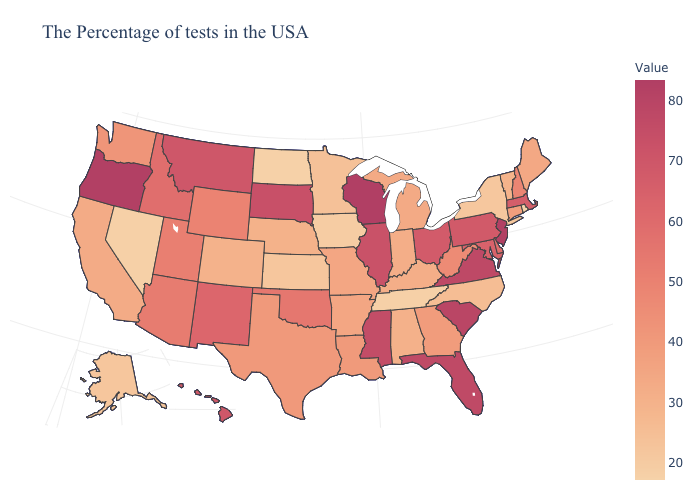Which states have the lowest value in the USA?
Write a very short answer. Rhode Island. Does Alaska have the lowest value in the USA?
Give a very brief answer. No. Among the states that border Minnesota , does South Dakota have the lowest value?
Quick response, please. No. 